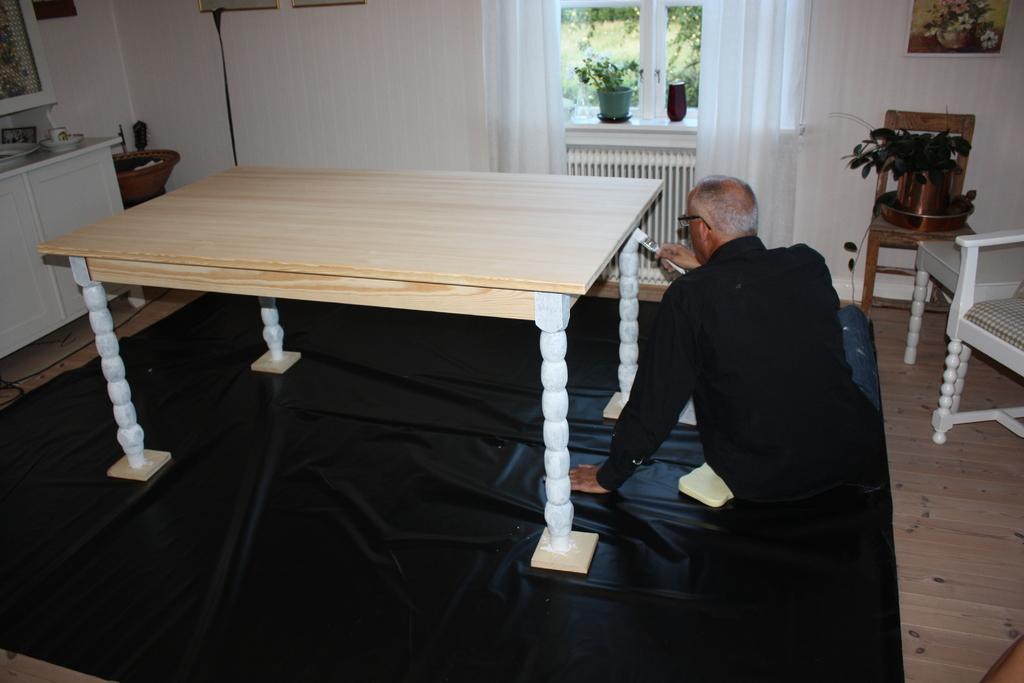In one or two sentences, can you explain what this image depicts? In this Image I see a man who is sitting on the floor and he is holding something and there is a table in front of him and I can also see 2 chairs, and stool and there is plant on this chair. In the background I see the wall on which there are few photo frames, another plant near to the window, curtains and the cabinets over here. 